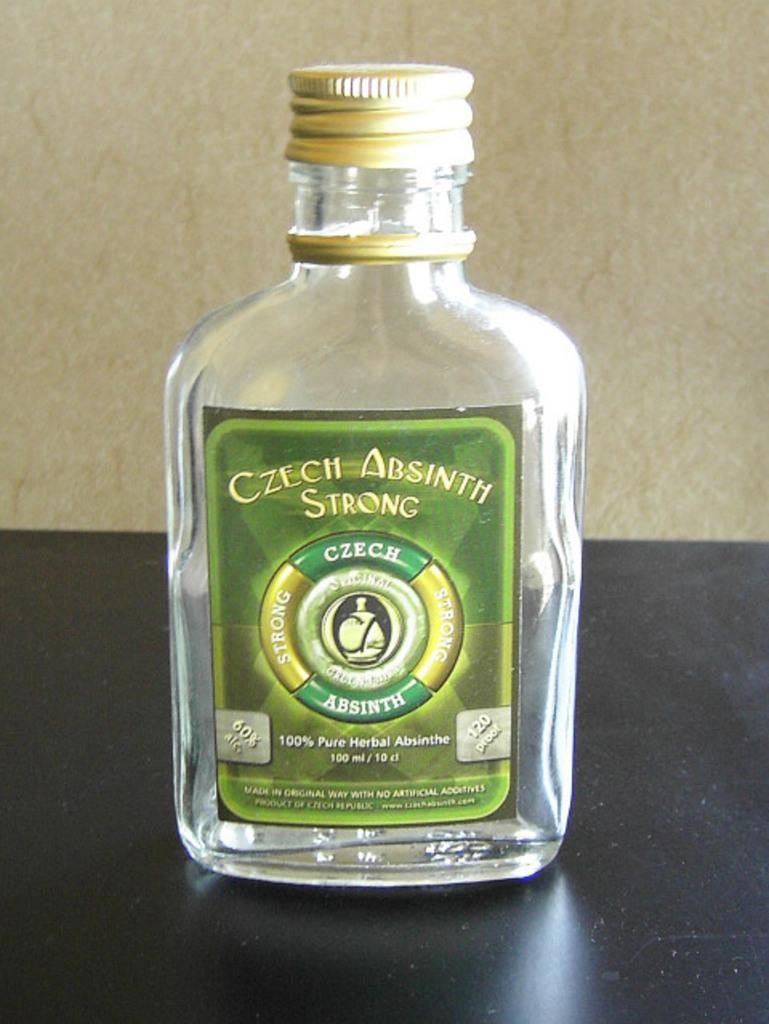<image>
Share a concise interpretation of the image provided. Almost empty bottle of Czech Absinth strong that is herbal 